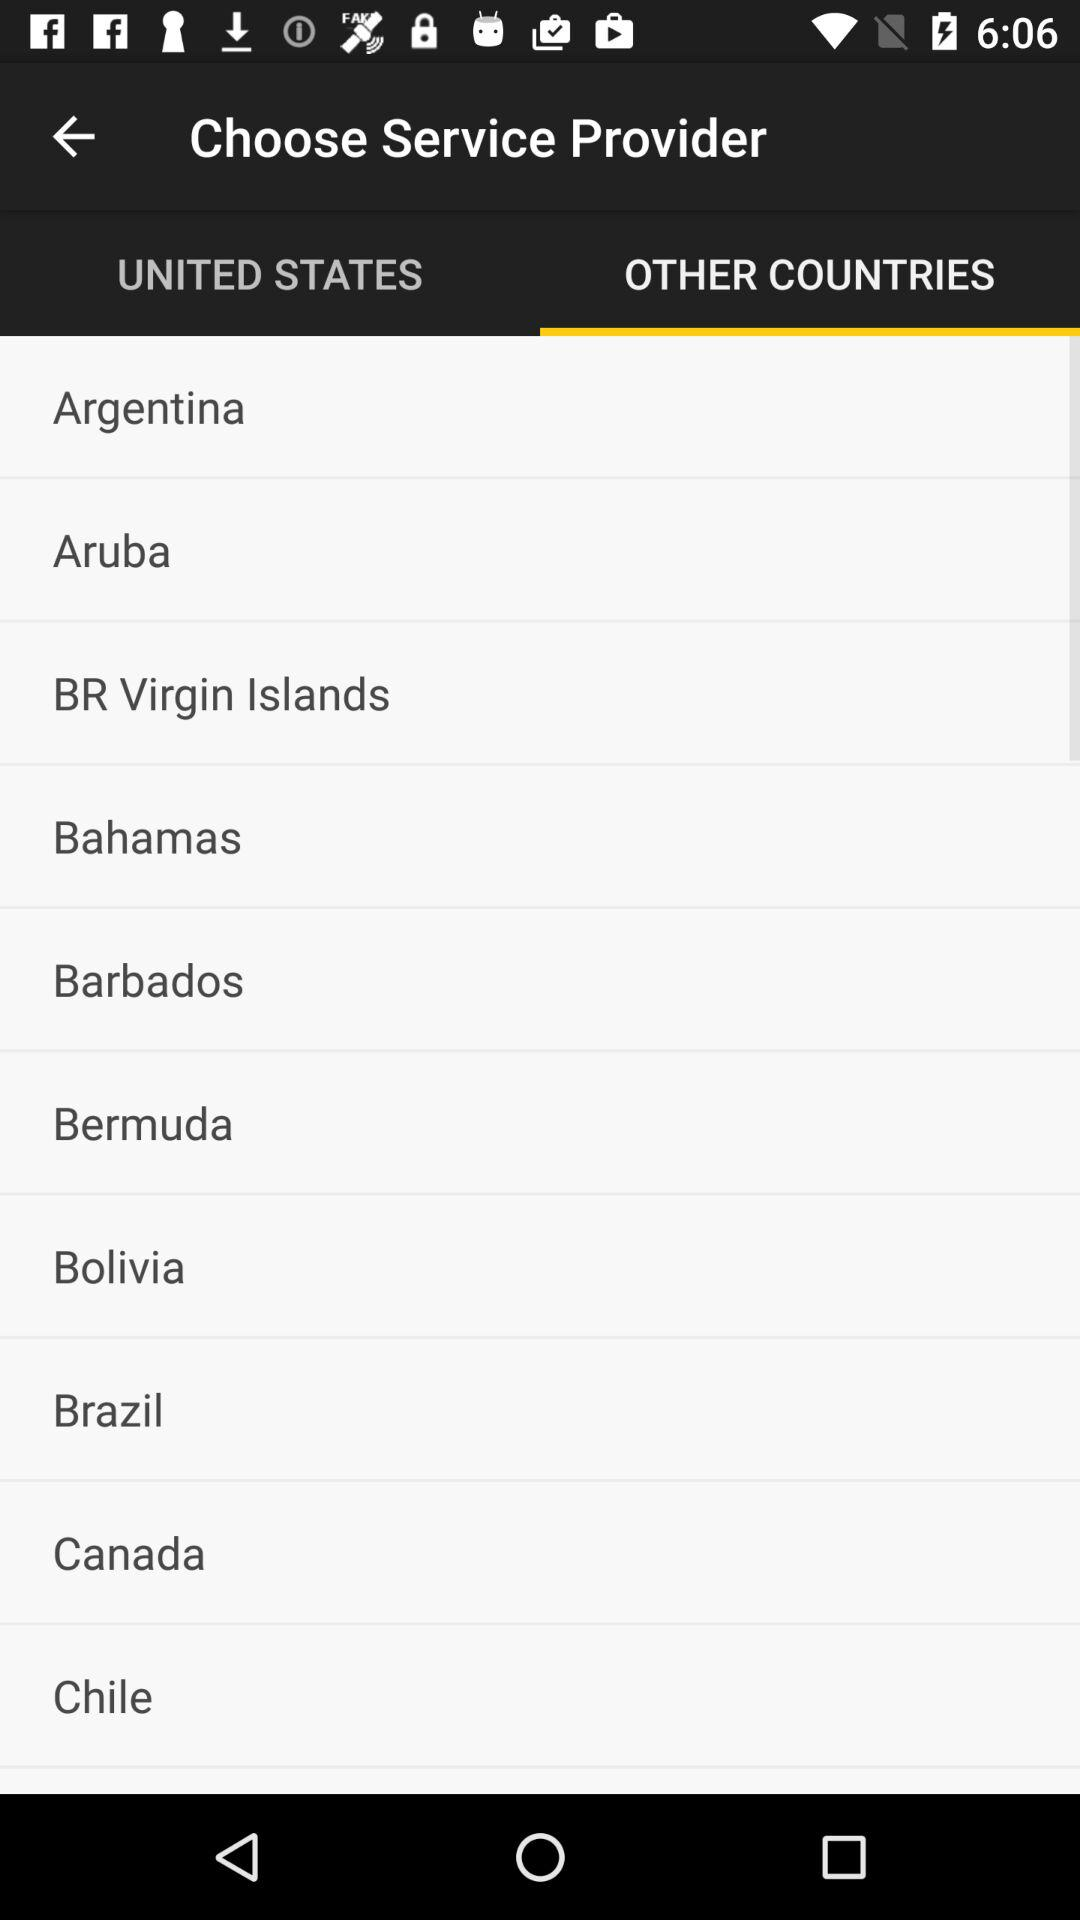Which tab is selected? The selected tab is "OTHER COUNTRIES". 